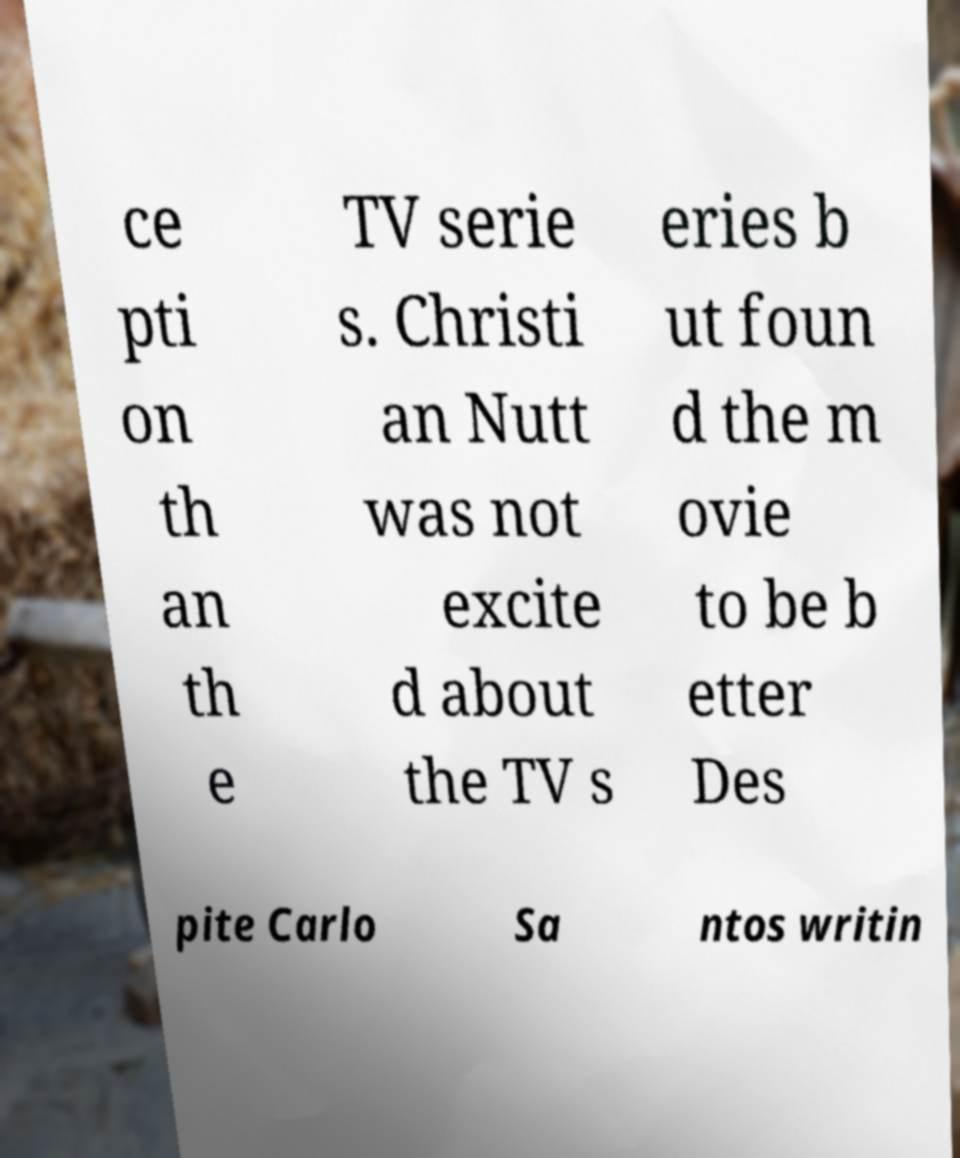Could you assist in decoding the text presented in this image and type it out clearly? ce pti on th an th e TV serie s. Christi an Nutt was not excite d about the TV s eries b ut foun d the m ovie to be b etter Des pite Carlo Sa ntos writin 